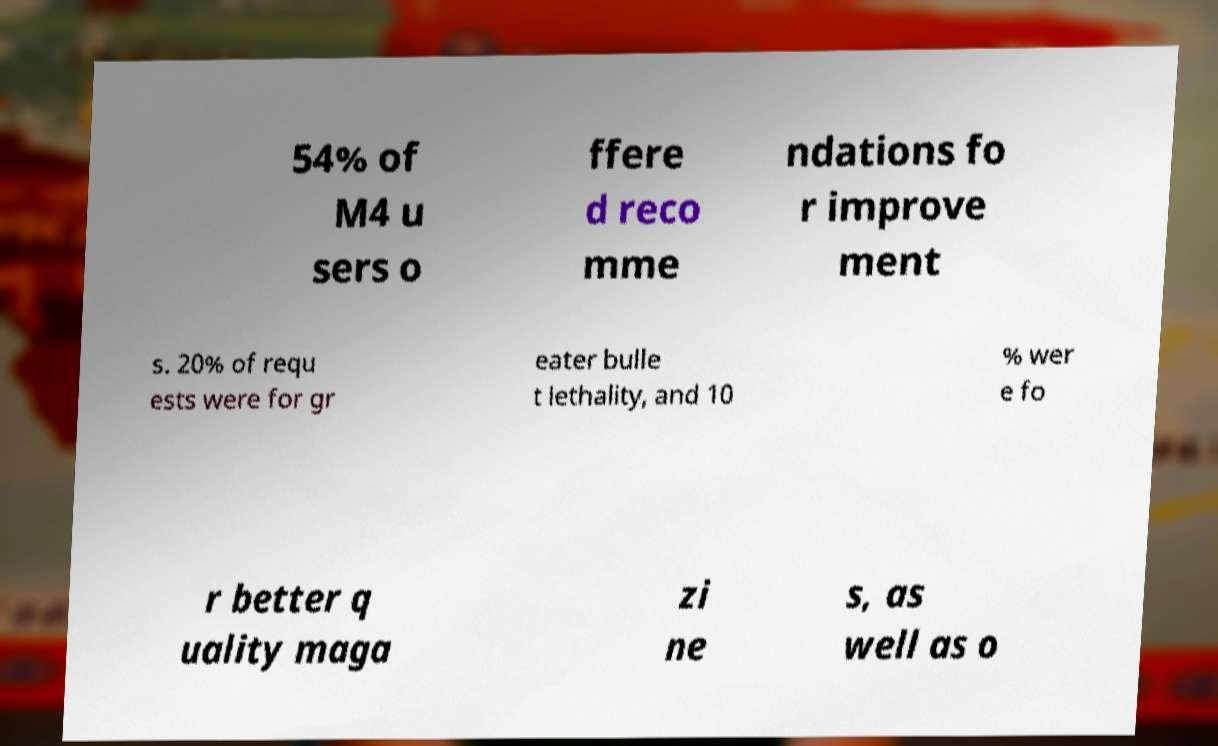There's text embedded in this image that I need extracted. Can you transcribe it verbatim? 54% of M4 u sers o ffere d reco mme ndations fo r improve ment s. 20% of requ ests were for gr eater bulle t lethality, and 10 % wer e fo r better q uality maga zi ne s, as well as o 